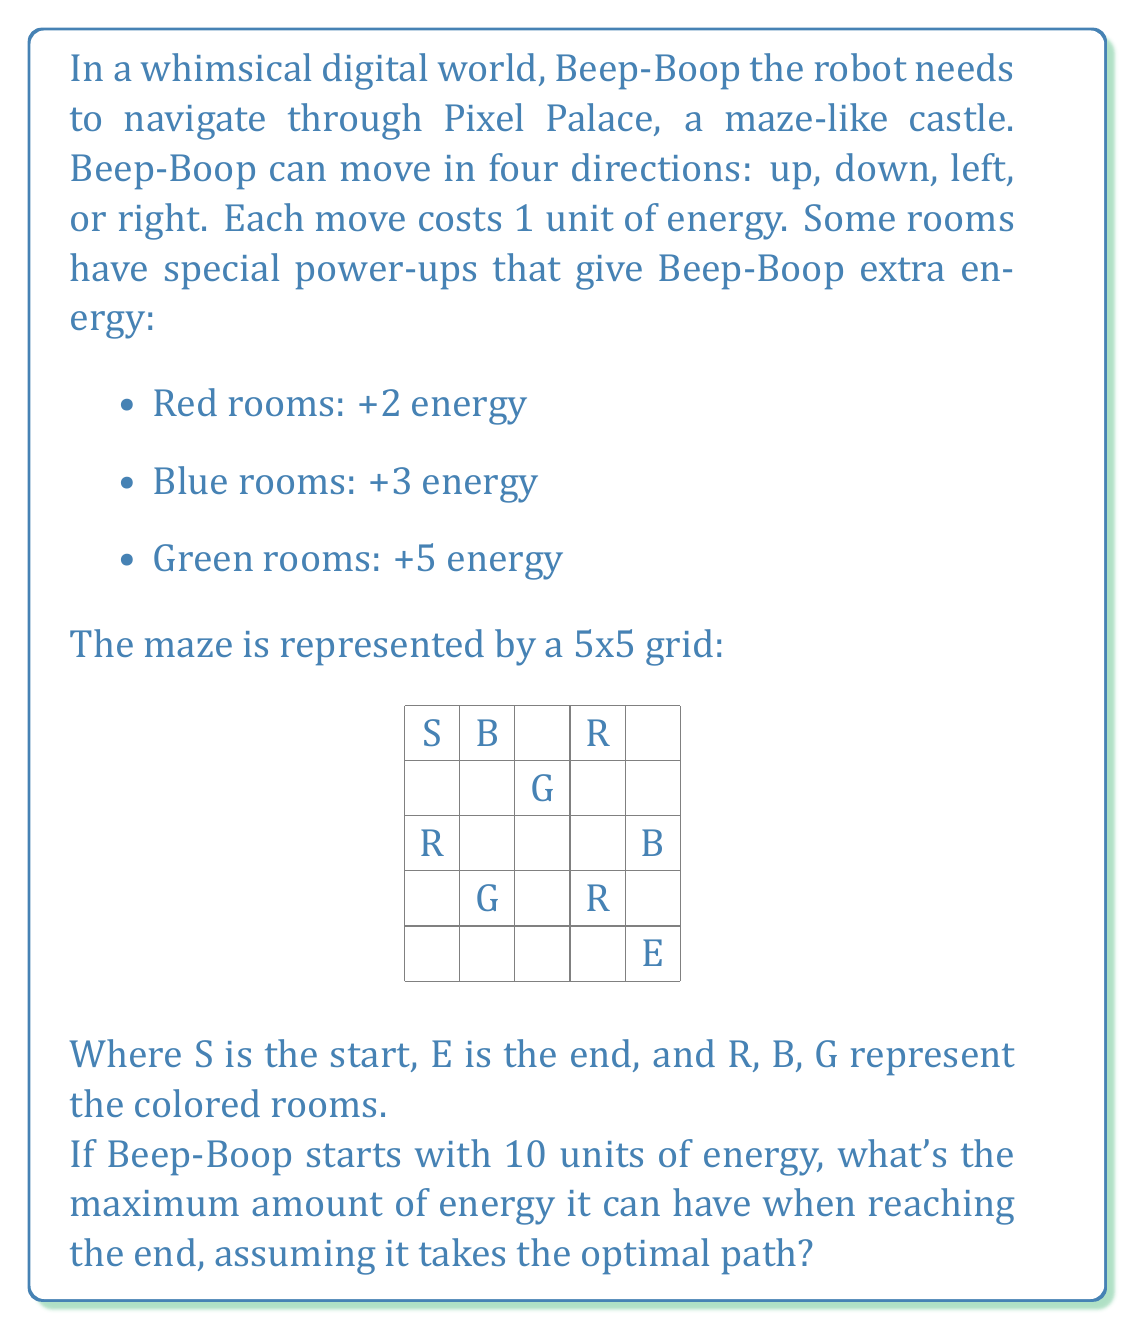Can you answer this question? To solve this problem, we need to find the path that maximizes Beep-Boop's energy at the end. We'll use a dynamic programming approach:

1) First, let's create a 5x5 grid to represent the energy gains/losses for each room:

   $$
   \begin{bmatrix}
   0 & 3 & 0 & 2 & 0 \\
   0 & 0 & 5 & 0 & 0 \\
   2 & 0 & 0 & 0 & 3 \\
   0 & 5 & 0 & 2 & 0 \\
   0 & 0 & 0 & 0 & 0
   \end{bmatrix}
   $$

2) Now, let's create a grid to store the maximum energy at each position. We'll fill this from bottom-right to top-left:

3) Initialize the end position (5,5) with 10 (starting energy).

4) For each position (i,j), calculate:
   $$\text{MaxEnergy}(i,j) = \max(\text{MaxEnergy}(i+1,j), \text{MaxEnergy}(i,j+1)) + \text{EnergyGain}(i,j) - 1$$

   The -1 is for the energy cost of moving.

5) After filling the grid, the value at (1,1) will be the maximum possible energy at the end.

6) The filled grid looks like this:

   $$
   \begin{bmatrix}
   22 & 24 & 21 & 22 & 19 \\
   21 & 20 & 24 & 19 & 18 \\
   22 & 19 & 18 & 17 & 20 \\
   19 & 23 & 17 & 18 & 15 \\
   17 & 16 & 14 & 12 & 10
   \end{bmatrix}
   $$

7) The optimal path can be traced by always moving to the position with higher energy:
   S -> B -> G -> G -> R -> B -> E

8) Starting energy: 10
   Gains: 3 + 5 + 5 + 2 + 3 = 18
   Moves: 6 (costing 6 energy)

9) Final energy: 10 + 18 - 6 = 22
Answer: The maximum amount of energy Beep-Boop can have when reaching the end is 22 units. 